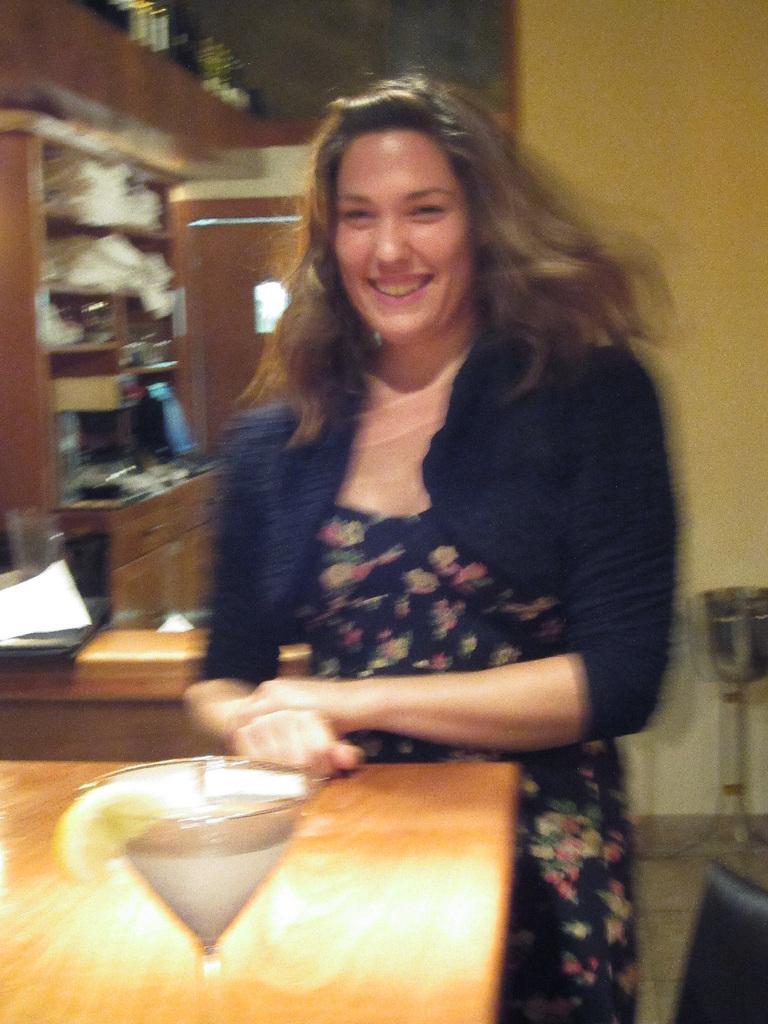Could you give a brief overview of what you see in this image? This image is taken indoors. In the background there is a wall. On the right side of the image there is a cupboard with a few things on it. At the bottom of the image there is a table with a glass on it. In the middle of the image a woman is standing and she is with a smiling face. On the right side of the image there is an empty chair. 